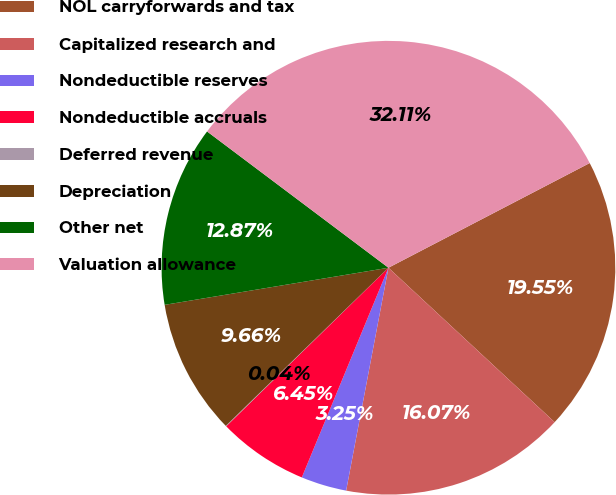Convert chart. <chart><loc_0><loc_0><loc_500><loc_500><pie_chart><fcel>NOL carryforwards and tax<fcel>Capitalized research and<fcel>Nondeductible reserves<fcel>Nondeductible accruals<fcel>Deferred revenue<fcel>Depreciation<fcel>Other net<fcel>Valuation allowance<nl><fcel>19.55%<fcel>16.07%<fcel>3.25%<fcel>6.45%<fcel>0.04%<fcel>9.66%<fcel>12.87%<fcel>32.11%<nl></chart> 